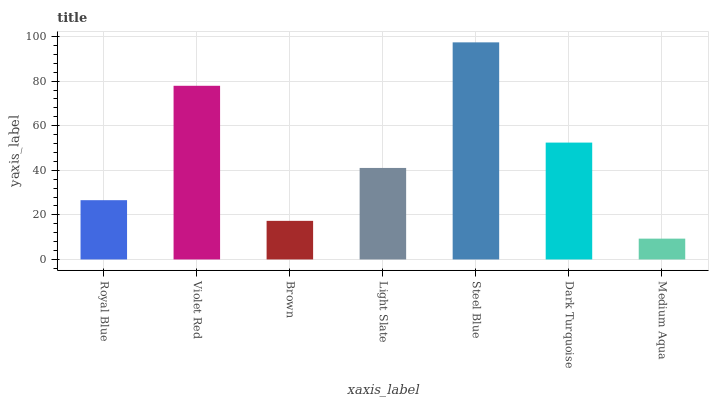Is Medium Aqua the minimum?
Answer yes or no. Yes. Is Steel Blue the maximum?
Answer yes or no. Yes. Is Violet Red the minimum?
Answer yes or no. No. Is Violet Red the maximum?
Answer yes or no. No. Is Violet Red greater than Royal Blue?
Answer yes or no. Yes. Is Royal Blue less than Violet Red?
Answer yes or no. Yes. Is Royal Blue greater than Violet Red?
Answer yes or no. No. Is Violet Red less than Royal Blue?
Answer yes or no. No. Is Light Slate the high median?
Answer yes or no. Yes. Is Light Slate the low median?
Answer yes or no. Yes. Is Medium Aqua the high median?
Answer yes or no. No. Is Steel Blue the low median?
Answer yes or no. No. 